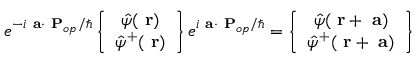Convert formula to latex. <formula><loc_0><loc_0><loc_500><loc_500>e ^ { - i a \cdot P _ { o p } / } \left \{ \begin{array} { c } { \hat { \psi } ( r ) } \\ { \hat { \psi } ^ { + } ( r ) } \end{array} \right \} e ^ { i a \cdot P _ { o p } / } = \left \{ \begin{array} { c } { \hat { \psi } ( r + a ) } \\ { \hat { \psi } ^ { + } ( r + a ) } \end{array} \right \}</formula> 